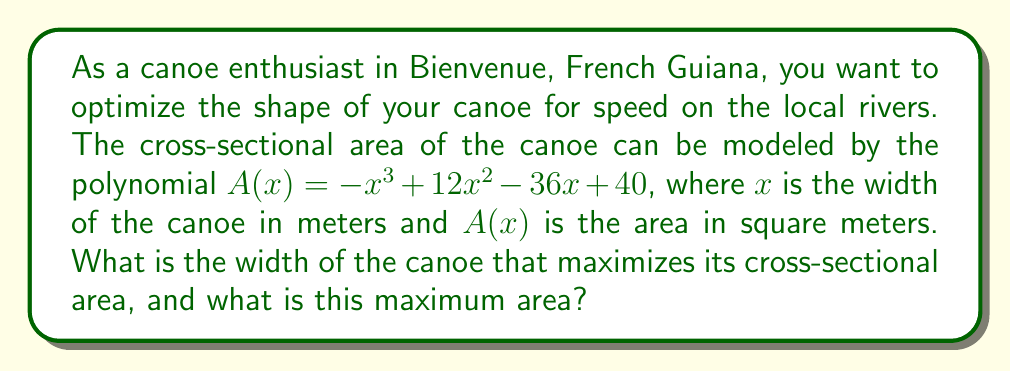Show me your answer to this math problem. To find the maximum cross-sectional area of the canoe, we need to follow these steps:

1) First, we need to find the derivative of $A(x)$:
   $$A'(x) = -3x^2 + 24x - 36$$

2) To find the critical points, we set $A'(x) = 0$:
   $$-3x^2 + 24x - 36 = 0$$

3) This is a quadratic equation. We can solve it using the quadratic formula:
   $$x = \frac{-b \pm \sqrt{b^2 - 4ac}}{2a}$$
   where $a = -3$, $b = 24$, and $c = -36$

4) Substituting these values:
   $$x = \frac{-24 \pm \sqrt{24^2 - 4(-3)(-36)}}{2(-3)}$$
   $$= \frac{-24 \pm \sqrt{576 - 432}}{-6}$$
   $$= \frac{-24 \pm \sqrt{144}}{-6}$$
   $$= \frac{-24 \pm 12}{-6}$$

5) This gives us two solutions:
   $$x_1 = \frac{-24 + 12}{-6} = 2$$
   $$x_2 = \frac{-24 - 12}{-6} = 6$$

6) To determine which of these gives the maximum, we can check the second derivative:
   $$A''(x) = -6x + 24$$
   At $x = 2$: $A''(2) = -6(2) + 24 = 12 > 0$
   At $x = 6$: $A''(6) = -6(6) + 24 = -12 < 0$

   Since $A''(2) > 0$, $x = 2$ gives a local minimum.
   Since $A''(6) < 0$, $x = 6$ gives a local maximum.

7) Therefore, the width that maximizes the cross-sectional area is 6 meters.

8) To find the maximum area, we substitute $x = 6$ into the original function:
   $$A(6) = -(6)^3 + 12(6)^2 - 36(6) + 40$$
   $$= -216 + 432 - 216 + 40$$
   $$= 40$$ square meters
Answer: The width of the canoe that maximizes its cross-sectional area is 6 meters, and the maximum cross-sectional area is 40 square meters. 